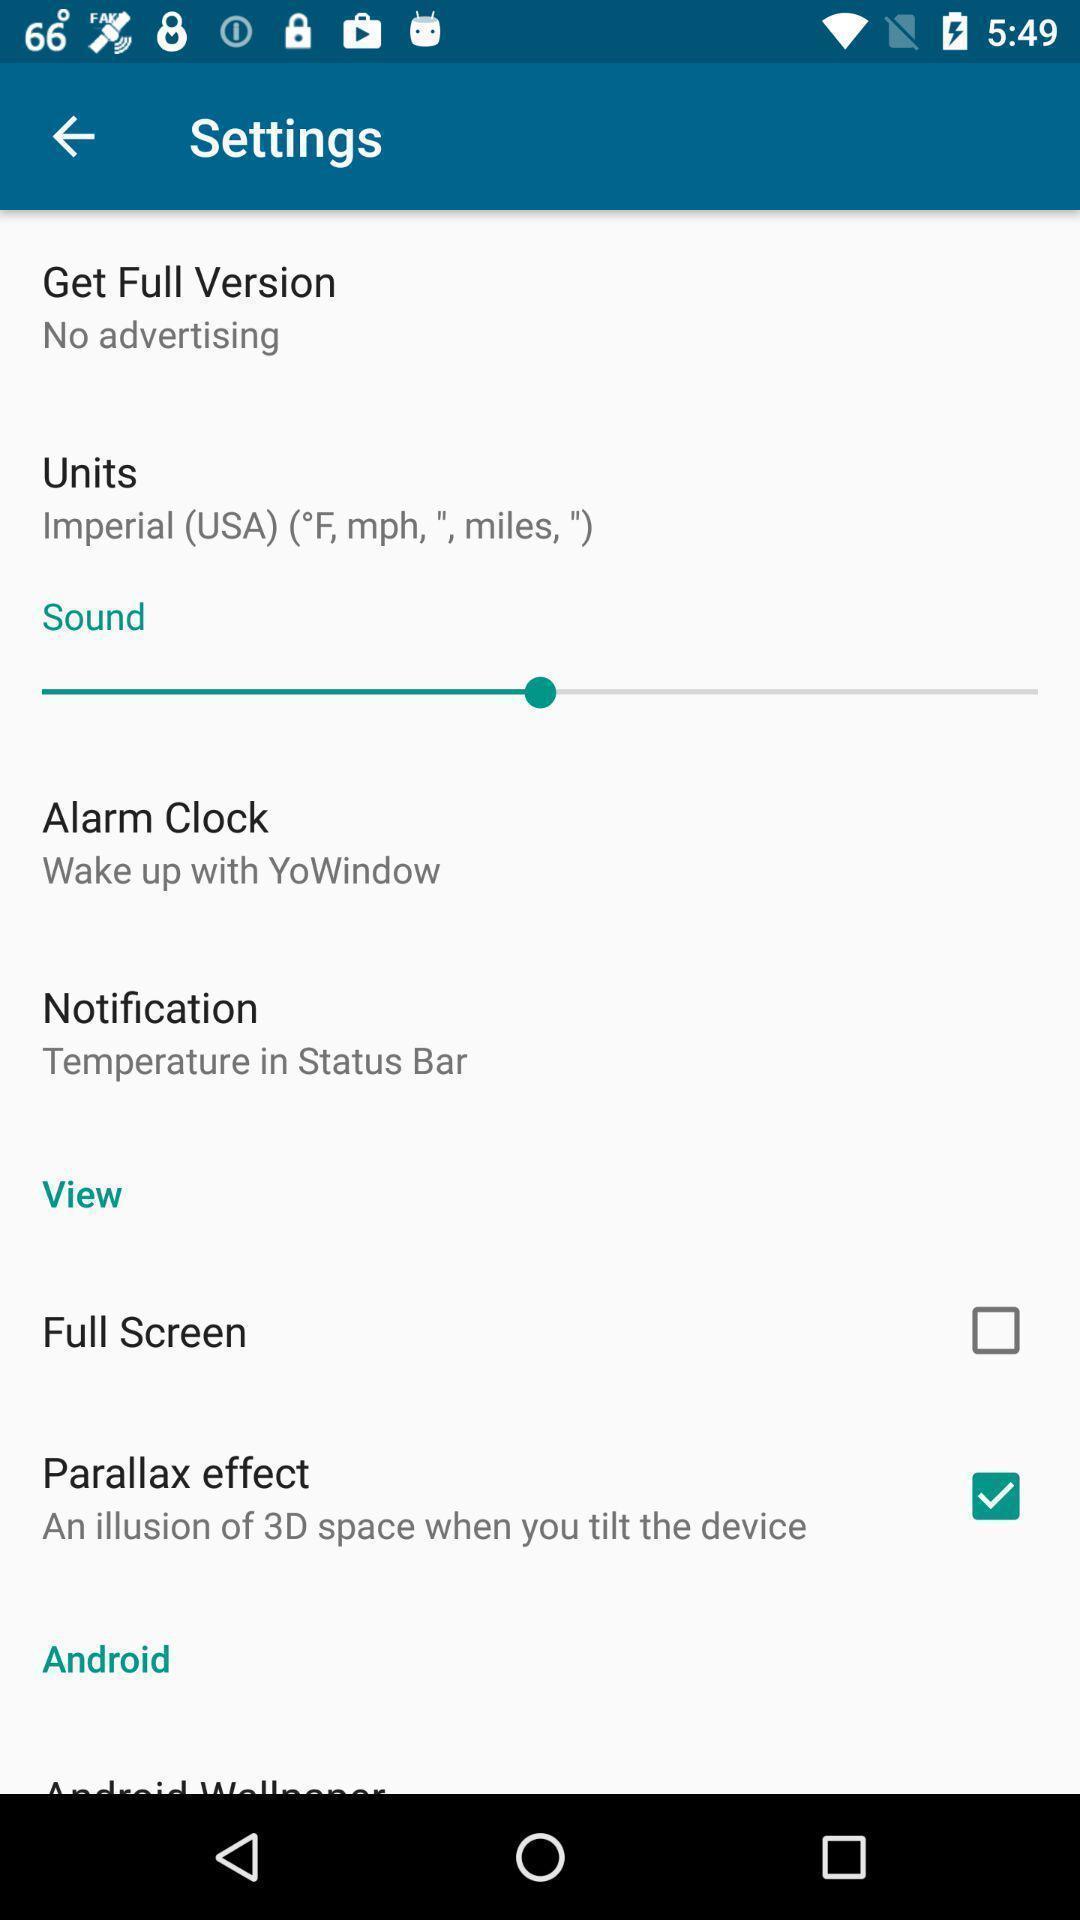Provide a textual representation of this image. Settings page in a weather app. 